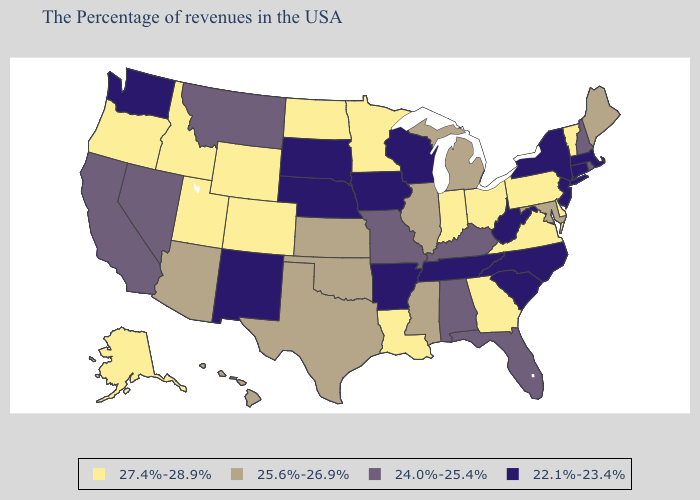Name the states that have a value in the range 27.4%-28.9%?
Keep it brief. Vermont, Delaware, Pennsylvania, Virginia, Ohio, Georgia, Indiana, Louisiana, Minnesota, North Dakota, Wyoming, Colorado, Utah, Idaho, Oregon, Alaska. Does New Hampshire have the lowest value in the USA?
Short answer required. No. What is the highest value in the Northeast ?
Quick response, please. 27.4%-28.9%. Which states have the lowest value in the USA?
Concise answer only. Massachusetts, Connecticut, New York, New Jersey, North Carolina, South Carolina, West Virginia, Tennessee, Wisconsin, Arkansas, Iowa, Nebraska, South Dakota, New Mexico, Washington. Which states hav the highest value in the Northeast?
Keep it brief. Vermont, Pennsylvania. Does Florida have the highest value in the USA?
Write a very short answer. No. Name the states that have a value in the range 22.1%-23.4%?
Keep it brief. Massachusetts, Connecticut, New York, New Jersey, North Carolina, South Carolina, West Virginia, Tennessee, Wisconsin, Arkansas, Iowa, Nebraska, South Dakota, New Mexico, Washington. Name the states that have a value in the range 22.1%-23.4%?
Quick response, please. Massachusetts, Connecticut, New York, New Jersey, North Carolina, South Carolina, West Virginia, Tennessee, Wisconsin, Arkansas, Iowa, Nebraska, South Dakota, New Mexico, Washington. Name the states that have a value in the range 27.4%-28.9%?
Concise answer only. Vermont, Delaware, Pennsylvania, Virginia, Ohio, Georgia, Indiana, Louisiana, Minnesota, North Dakota, Wyoming, Colorado, Utah, Idaho, Oregon, Alaska. Name the states that have a value in the range 25.6%-26.9%?
Quick response, please. Maine, Maryland, Michigan, Illinois, Mississippi, Kansas, Oklahoma, Texas, Arizona, Hawaii. Does Louisiana have a higher value than North Carolina?
Keep it brief. Yes. What is the value of Virginia?
Keep it brief. 27.4%-28.9%. Which states have the lowest value in the USA?
Write a very short answer. Massachusetts, Connecticut, New York, New Jersey, North Carolina, South Carolina, West Virginia, Tennessee, Wisconsin, Arkansas, Iowa, Nebraska, South Dakota, New Mexico, Washington. What is the value of West Virginia?
Answer briefly. 22.1%-23.4%. 